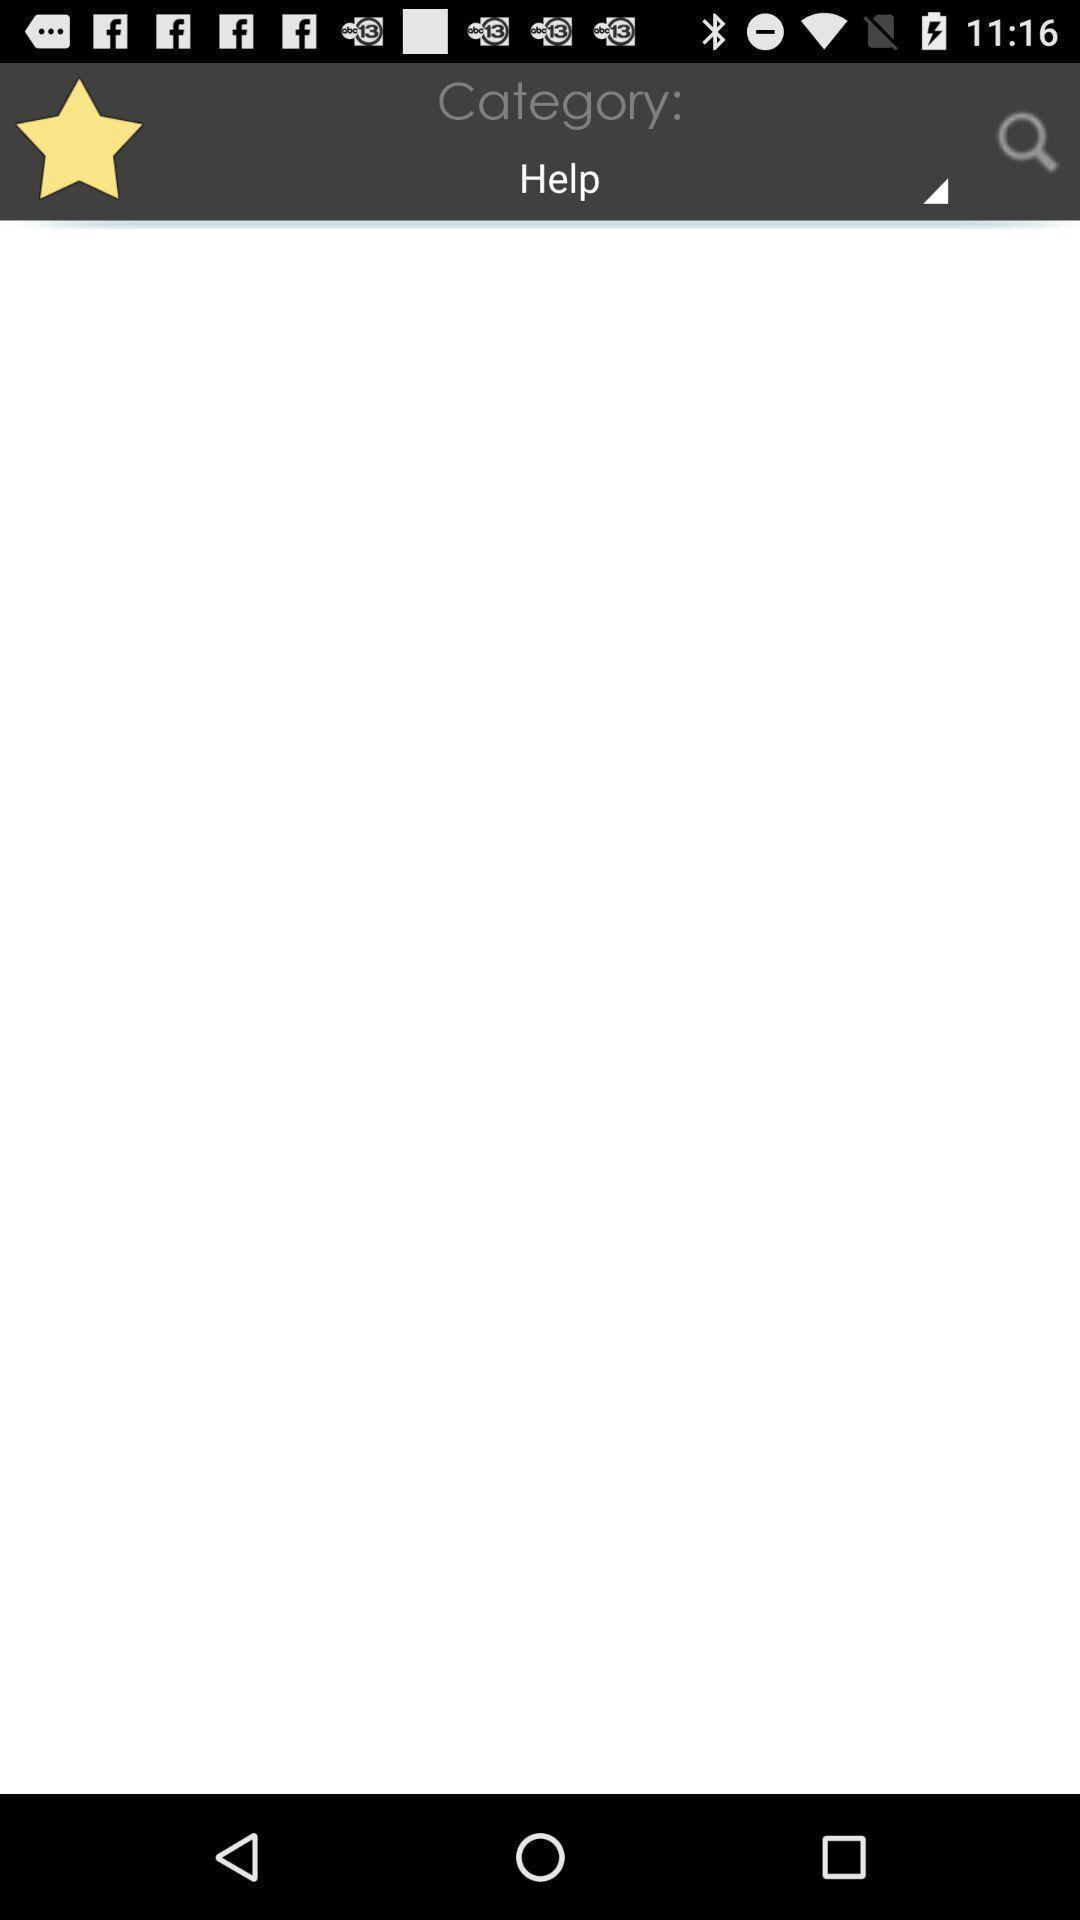Describe this image in words. Page displaying blank information about help category. 